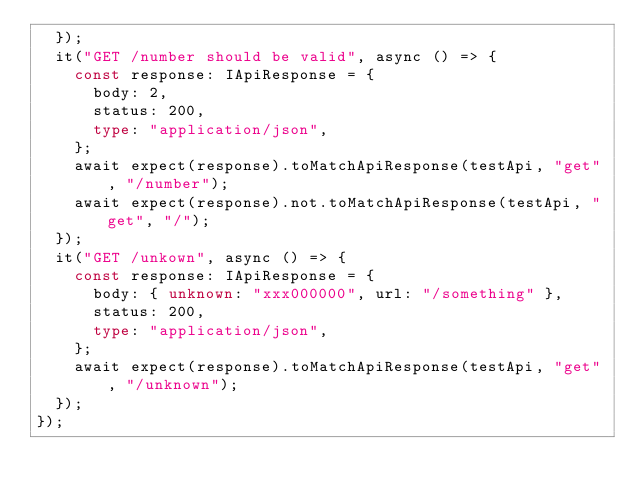<code> <loc_0><loc_0><loc_500><loc_500><_TypeScript_>  });
  it("GET /number should be valid", async () => {
    const response: IApiResponse = {
      body: 2,
      status: 200,
      type: "application/json",
    };
    await expect(response).toMatchApiResponse(testApi, "get", "/number");
    await expect(response).not.toMatchApiResponse(testApi, "get", "/");
  });
  it("GET /unkown", async () => {
    const response: IApiResponse = {
      body: { unknown: "xxx000000", url: "/something" },
      status: 200,
      type: "application/json",
    };
    await expect(response).toMatchApiResponse(testApi, "get", "/unknown");
  });
});
</code> 